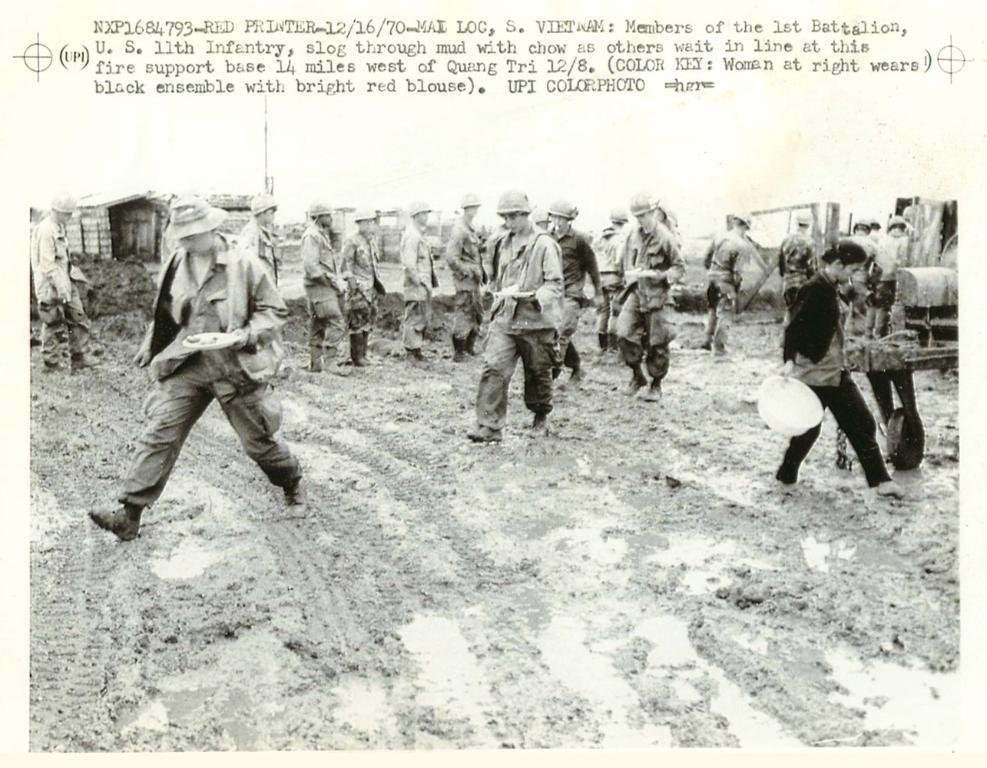Describe this image in one or two sentences. In the foreground there is mud. In the middle of the picture there are people, mud, vehicles and other objects. At the top there is sky and text. 